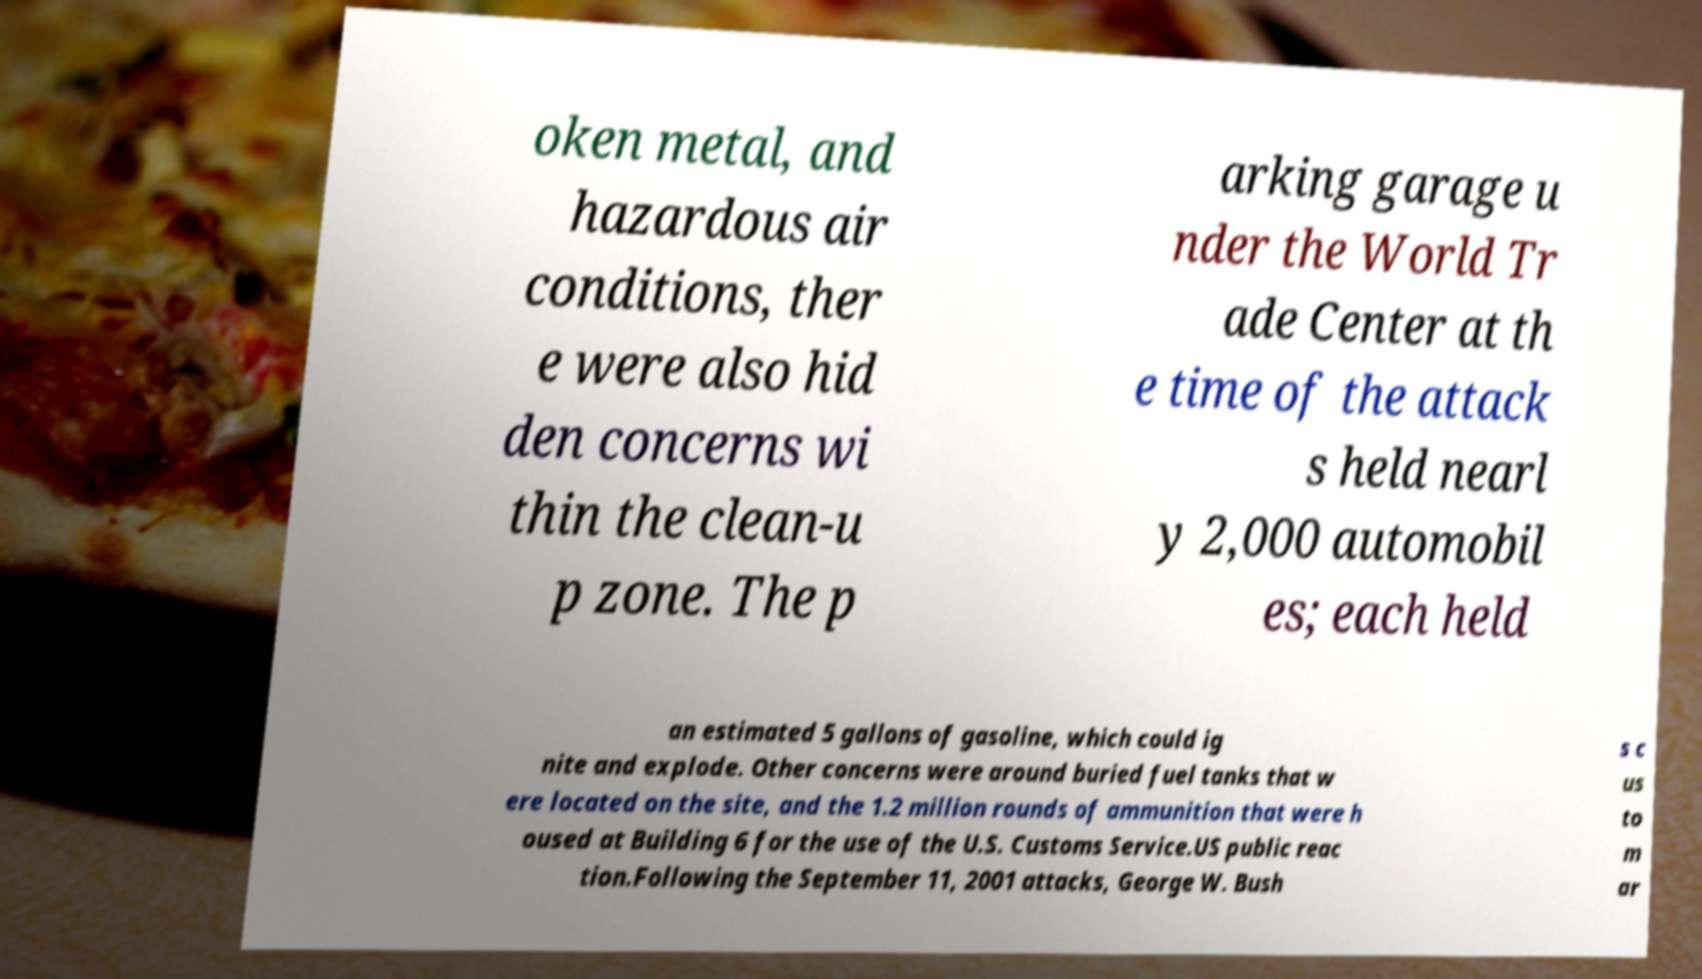Could you assist in decoding the text presented in this image and type it out clearly? oken metal, and hazardous air conditions, ther e were also hid den concerns wi thin the clean-u p zone. The p arking garage u nder the World Tr ade Center at th e time of the attack s held nearl y 2,000 automobil es; each held an estimated 5 gallons of gasoline, which could ig nite and explode. Other concerns were around buried fuel tanks that w ere located on the site, and the 1.2 million rounds of ammunition that were h oused at Building 6 for the use of the U.S. Customs Service.US public reac tion.Following the September 11, 2001 attacks, George W. Bush s c us to m ar 